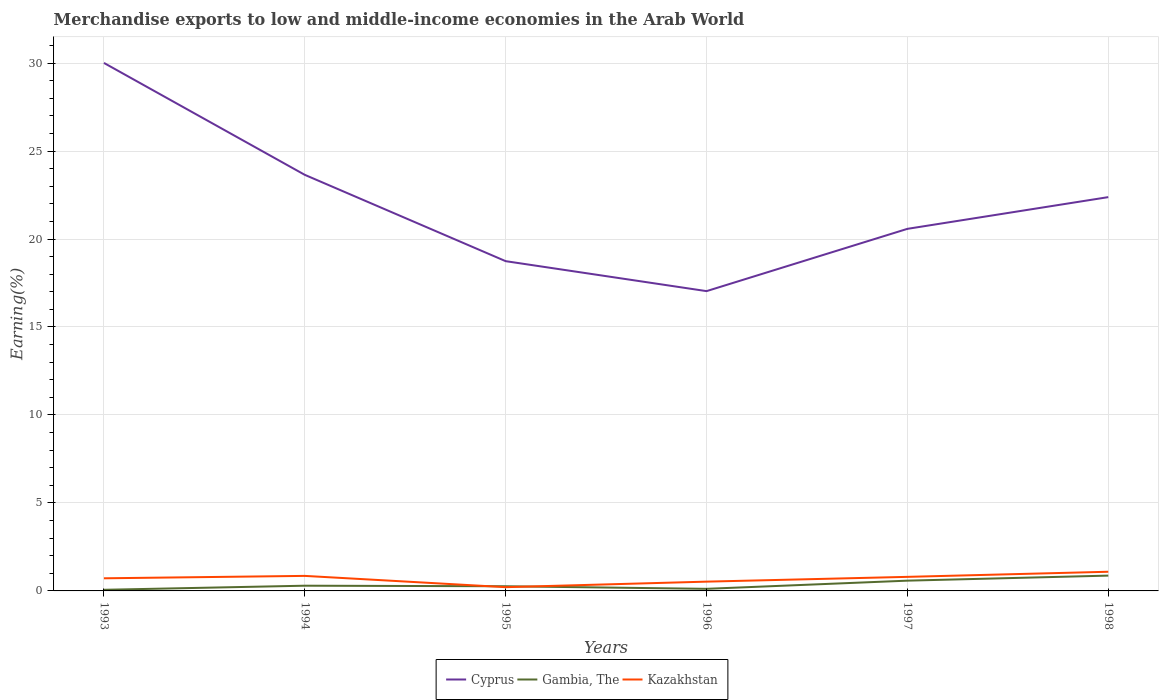How many different coloured lines are there?
Give a very brief answer. 3. Does the line corresponding to Kazakhstan intersect with the line corresponding to Cyprus?
Your response must be concise. No. Across all years, what is the maximum percentage of amount earned from merchandise exports in Cyprus?
Your answer should be very brief. 17.04. What is the total percentage of amount earned from merchandise exports in Cyprus in the graph?
Ensure brevity in your answer.  6.61. What is the difference between the highest and the second highest percentage of amount earned from merchandise exports in Kazakhstan?
Provide a short and direct response. 0.88. What is the difference between the highest and the lowest percentage of amount earned from merchandise exports in Cyprus?
Ensure brevity in your answer.  3. What is the difference between two consecutive major ticks on the Y-axis?
Ensure brevity in your answer.  5. Are the values on the major ticks of Y-axis written in scientific E-notation?
Your response must be concise. No. Does the graph contain grids?
Provide a succinct answer. Yes. Where does the legend appear in the graph?
Offer a very short reply. Bottom center. What is the title of the graph?
Ensure brevity in your answer.  Merchandise exports to low and middle-income economies in the Arab World. Does "Somalia" appear as one of the legend labels in the graph?
Offer a very short reply. No. What is the label or title of the X-axis?
Make the answer very short. Years. What is the label or title of the Y-axis?
Offer a very short reply. Earning(%). What is the Earning(%) of Cyprus in 1993?
Your response must be concise. 30.01. What is the Earning(%) of Gambia, The in 1993?
Provide a succinct answer. 0.06. What is the Earning(%) in Kazakhstan in 1993?
Your answer should be compact. 0.72. What is the Earning(%) of Cyprus in 1994?
Offer a terse response. 23.65. What is the Earning(%) of Gambia, The in 1994?
Give a very brief answer. 0.3. What is the Earning(%) of Kazakhstan in 1994?
Keep it short and to the point. 0.85. What is the Earning(%) of Cyprus in 1995?
Offer a very short reply. 18.74. What is the Earning(%) in Gambia, The in 1995?
Your answer should be very brief. 0.27. What is the Earning(%) of Kazakhstan in 1995?
Provide a succinct answer. 0.21. What is the Earning(%) in Cyprus in 1996?
Provide a succinct answer. 17.04. What is the Earning(%) of Gambia, The in 1996?
Offer a terse response. 0.12. What is the Earning(%) of Kazakhstan in 1996?
Make the answer very short. 0.53. What is the Earning(%) of Cyprus in 1997?
Keep it short and to the point. 20.58. What is the Earning(%) in Gambia, The in 1997?
Your answer should be compact. 0.58. What is the Earning(%) of Kazakhstan in 1997?
Provide a short and direct response. 0.8. What is the Earning(%) of Cyprus in 1998?
Offer a terse response. 22.38. What is the Earning(%) in Gambia, The in 1998?
Your answer should be very brief. 0.87. What is the Earning(%) of Kazakhstan in 1998?
Provide a succinct answer. 1.09. Across all years, what is the maximum Earning(%) of Cyprus?
Keep it short and to the point. 30.01. Across all years, what is the maximum Earning(%) in Gambia, The?
Provide a succinct answer. 0.87. Across all years, what is the maximum Earning(%) of Kazakhstan?
Give a very brief answer. 1.09. Across all years, what is the minimum Earning(%) in Cyprus?
Your response must be concise. 17.04. Across all years, what is the minimum Earning(%) in Gambia, The?
Ensure brevity in your answer.  0.06. Across all years, what is the minimum Earning(%) of Kazakhstan?
Offer a terse response. 0.21. What is the total Earning(%) in Cyprus in the graph?
Your answer should be compact. 132.39. What is the total Earning(%) of Gambia, The in the graph?
Your response must be concise. 2.2. What is the total Earning(%) in Kazakhstan in the graph?
Give a very brief answer. 4.2. What is the difference between the Earning(%) of Cyprus in 1993 and that in 1994?
Provide a short and direct response. 6.36. What is the difference between the Earning(%) of Gambia, The in 1993 and that in 1994?
Give a very brief answer. -0.23. What is the difference between the Earning(%) in Kazakhstan in 1993 and that in 1994?
Offer a very short reply. -0.14. What is the difference between the Earning(%) of Cyprus in 1993 and that in 1995?
Your answer should be compact. 11.27. What is the difference between the Earning(%) in Gambia, The in 1993 and that in 1995?
Keep it short and to the point. -0.2. What is the difference between the Earning(%) of Kazakhstan in 1993 and that in 1995?
Give a very brief answer. 0.5. What is the difference between the Earning(%) of Cyprus in 1993 and that in 1996?
Your response must be concise. 12.97. What is the difference between the Earning(%) of Gambia, The in 1993 and that in 1996?
Provide a succinct answer. -0.06. What is the difference between the Earning(%) in Kazakhstan in 1993 and that in 1996?
Keep it short and to the point. 0.19. What is the difference between the Earning(%) in Cyprus in 1993 and that in 1997?
Offer a terse response. 9.43. What is the difference between the Earning(%) of Gambia, The in 1993 and that in 1997?
Ensure brevity in your answer.  -0.52. What is the difference between the Earning(%) in Kazakhstan in 1993 and that in 1997?
Your answer should be very brief. -0.08. What is the difference between the Earning(%) in Cyprus in 1993 and that in 1998?
Offer a terse response. 7.63. What is the difference between the Earning(%) of Gambia, The in 1993 and that in 1998?
Your response must be concise. -0.81. What is the difference between the Earning(%) of Kazakhstan in 1993 and that in 1998?
Your answer should be very brief. -0.37. What is the difference between the Earning(%) of Cyprus in 1994 and that in 1995?
Provide a succinct answer. 4.91. What is the difference between the Earning(%) of Gambia, The in 1994 and that in 1995?
Your response must be concise. 0.03. What is the difference between the Earning(%) of Kazakhstan in 1994 and that in 1995?
Offer a very short reply. 0.64. What is the difference between the Earning(%) in Cyprus in 1994 and that in 1996?
Provide a short and direct response. 6.61. What is the difference between the Earning(%) in Gambia, The in 1994 and that in 1996?
Keep it short and to the point. 0.18. What is the difference between the Earning(%) in Kazakhstan in 1994 and that in 1996?
Your response must be concise. 0.33. What is the difference between the Earning(%) in Cyprus in 1994 and that in 1997?
Give a very brief answer. 3.07. What is the difference between the Earning(%) in Gambia, The in 1994 and that in 1997?
Ensure brevity in your answer.  -0.29. What is the difference between the Earning(%) of Kazakhstan in 1994 and that in 1997?
Offer a very short reply. 0.06. What is the difference between the Earning(%) of Cyprus in 1994 and that in 1998?
Ensure brevity in your answer.  1.27. What is the difference between the Earning(%) of Gambia, The in 1994 and that in 1998?
Offer a very short reply. -0.57. What is the difference between the Earning(%) of Kazakhstan in 1994 and that in 1998?
Provide a short and direct response. -0.24. What is the difference between the Earning(%) of Cyprus in 1995 and that in 1996?
Your response must be concise. 1.7. What is the difference between the Earning(%) of Gambia, The in 1995 and that in 1996?
Offer a very short reply. 0.15. What is the difference between the Earning(%) in Kazakhstan in 1995 and that in 1996?
Make the answer very short. -0.31. What is the difference between the Earning(%) of Cyprus in 1995 and that in 1997?
Provide a short and direct response. -1.84. What is the difference between the Earning(%) in Gambia, The in 1995 and that in 1997?
Offer a terse response. -0.32. What is the difference between the Earning(%) in Kazakhstan in 1995 and that in 1997?
Your response must be concise. -0.59. What is the difference between the Earning(%) of Cyprus in 1995 and that in 1998?
Ensure brevity in your answer.  -3.64. What is the difference between the Earning(%) of Gambia, The in 1995 and that in 1998?
Your response must be concise. -0.6. What is the difference between the Earning(%) in Kazakhstan in 1995 and that in 1998?
Provide a succinct answer. -0.88. What is the difference between the Earning(%) of Cyprus in 1996 and that in 1997?
Ensure brevity in your answer.  -3.54. What is the difference between the Earning(%) in Gambia, The in 1996 and that in 1997?
Keep it short and to the point. -0.46. What is the difference between the Earning(%) of Kazakhstan in 1996 and that in 1997?
Offer a very short reply. -0.27. What is the difference between the Earning(%) in Cyprus in 1996 and that in 1998?
Your answer should be very brief. -5.34. What is the difference between the Earning(%) of Gambia, The in 1996 and that in 1998?
Keep it short and to the point. -0.75. What is the difference between the Earning(%) in Kazakhstan in 1996 and that in 1998?
Give a very brief answer. -0.56. What is the difference between the Earning(%) of Cyprus in 1997 and that in 1998?
Provide a succinct answer. -1.8. What is the difference between the Earning(%) of Gambia, The in 1997 and that in 1998?
Provide a short and direct response. -0.29. What is the difference between the Earning(%) of Kazakhstan in 1997 and that in 1998?
Ensure brevity in your answer.  -0.29. What is the difference between the Earning(%) of Cyprus in 1993 and the Earning(%) of Gambia, The in 1994?
Give a very brief answer. 29.71. What is the difference between the Earning(%) of Cyprus in 1993 and the Earning(%) of Kazakhstan in 1994?
Your answer should be very brief. 29.15. What is the difference between the Earning(%) of Gambia, The in 1993 and the Earning(%) of Kazakhstan in 1994?
Your response must be concise. -0.79. What is the difference between the Earning(%) in Cyprus in 1993 and the Earning(%) in Gambia, The in 1995?
Make the answer very short. 29.74. What is the difference between the Earning(%) of Cyprus in 1993 and the Earning(%) of Kazakhstan in 1995?
Your answer should be very brief. 29.79. What is the difference between the Earning(%) of Gambia, The in 1993 and the Earning(%) of Kazakhstan in 1995?
Your answer should be compact. -0.15. What is the difference between the Earning(%) in Cyprus in 1993 and the Earning(%) in Gambia, The in 1996?
Your response must be concise. 29.89. What is the difference between the Earning(%) in Cyprus in 1993 and the Earning(%) in Kazakhstan in 1996?
Keep it short and to the point. 29.48. What is the difference between the Earning(%) of Gambia, The in 1993 and the Earning(%) of Kazakhstan in 1996?
Offer a very short reply. -0.46. What is the difference between the Earning(%) of Cyprus in 1993 and the Earning(%) of Gambia, The in 1997?
Your answer should be compact. 29.42. What is the difference between the Earning(%) in Cyprus in 1993 and the Earning(%) in Kazakhstan in 1997?
Your response must be concise. 29.21. What is the difference between the Earning(%) in Gambia, The in 1993 and the Earning(%) in Kazakhstan in 1997?
Give a very brief answer. -0.74. What is the difference between the Earning(%) of Cyprus in 1993 and the Earning(%) of Gambia, The in 1998?
Offer a very short reply. 29.14. What is the difference between the Earning(%) of Cyprus in 1993 and the Earning(%) of Kazakhstan in 1998?
Your answer should be very brief. 28.92. What is the difference between the Earning(%) of Gambia, The in 1993 and the Earning(%) of Kazakhstan in 1998?
Your response must be concise. -1.03. What is the difference between the Earning(%) of Cyprus in 1994 and the Earning(%) of Gambia, The in 1995?
Ensure brevity in your answer.  23.38. What is the difference between the Earning(%) of Cyprus in 1994 and the Earning(%) of Kazakhstan in 1995?
Provide a short and direct response. 23.43. What is the difference between the Earning(%) of Gambia, The in 1994 and the Earning(%) of Kazakhstan in 1995?
Provide a short and direct response. 0.08. What is the difference between the Earning(%) in Cyprus in 1994 and the Earning(%) in Gambia, The in 1996?
Give a very brief answer. 23.53. What is the difference between the Earning(%) in Cyprus in 1994 and the Earning(%) in Kazakhstan in 1996?
Offer a very short reply. 23.12. What is the difference between the Earning(%) in Gambia, The in 1994 and the Earning(%) in Kazakhstan in 1996?
Your response must be concise. -0.23. What is the difference between the Earning(%) in Cyprus in 1994 and the Earning(%) in Gambia, The in 1997?
Keep it short and to the point. 23.06. What is the difference between the Earning(%) in Cyprus in 1994 and the Earning(%) in Kazakhstan in 1997?
Provide a short and direct response. 22.85. What is the difference between the Earning(%) in Gambia, The in 1994 and the Earning(%) in Kazakhstan in 1997?
Your answer should be compact. -0.5. What is the difference between the Earning(%) of Cyprus in 1994 and the Earning(%) of Gambia, The in 1998?
Ensure brevity in your answer.  22.78. What is the difference between the Earning(%) in Cyprus in 1994 and the Earning(%) in Kazakhstan in 1998?
Make the answer very short. 22.56. What is the difference between the Earning(%) in Gambia, The in 1994 and the Earning(%) in Kazakhstan in 1998?
Provide a succinct answer. -0.79. What is the difference between the Earning(%) in Cyprus in 1995 and the Earning(%) in Gambia, The in 1996?
Provide a succinct answer. 18.62. What is the difference between the Earning(%) of Cyprus in 1995 and the Earning(%) of Kazakhstan in 1996?
Make the answer very short. 18.21. What is the difference between the Earning(%) of Gambia, The in 1995 and the Earning(%) of Kazakhstan in 1996?
Your answer should be very brief. -0.26. What is the difference between the Earning(%) of Cyprus in 1995 and the Earning(%) of Gambia, The in 1997?
Ensure brevity in your answer.  18.16. What is the difference between the Earning(%) of Cyprus in 1995 and the Earning(%) of Kazakhstan in 1997?
Your answer should be very brief. 17.94. What is the difference between the Earning(%) in Gambia, The in 1995 and the Earning(%) in Kazakhstan in 1997?
Ensure brevity in your answer.  -0.53. What is the difference between the Earning(%) in Cyprus in 1995 and the Earning(%) in Gambia, The in 1998?
Give a very brief answer. 17.87. What is the difference between the Earning(%) in Cyprus in 1995 and the Earning(%) in Kazakhstan in 1998?
Your response must be concise. 17.65. What is the difference between the Earning(%) in Gambia, The in 1995 and the Earning(%) in Kazakhstan in 1998?
Ensure brevity in your answer.  -0.82. What is the difference between the Earning(%) in Cyprus in 1996 and the Earning(%) in Gambia, The in 1997?
Your response must be concise. 16.45. What is the difference between the Earning(%) of Cyprus in 1996 and the Earning(%) of Kazakhstan in 1997?
Ensure brevity in your answer.  16.24. What is the difference between the Earning(%) in Gambia, The in 1996 and the Earning(%) in Kazakhstan in 1997?
Your answer should be compact. -0.68. What is the difference between the Earning(%) in Cyprus in 1996 and the Earning(%) in Gambia, The in 1998?
Your answer should be very brief. 16.17. What is the difference between the Earning(%) in Cyprus in 1996 and the Earning(%) in Kazakhstan in 1998?
Give a very brief answer. 15.95. What is the difference between the Earning(%) in Gambia, The in 1996 and the Earning(%) in Kazakhstan in 1998?
Make the answer very short. -0.97. What is the difference between the Earning(%) of Cyprus in 1997 and the Earning(%) of Gambia, The in 1998?
Your answer should be compact. 19.71. What is the difference between the Earning(%) in Cyprus in 1997 and the Earning(%) in Kazakhstan in 1998?
Give a very brief answer. 19.49. What is the difference between the Earning(%) in Gambia, The in 1997 and the Earning(%) in Kazakhstan in 1998?
Ensure brevity in your answer.  -0.51. What is the average Earning(%) in Cyprus per year?
Give a very brief answer. 22.06. What is the average Earning(%) in Gambia, The per year?
Provide a succinct answer. 0.37. What is the average Earning(%) of Kazakhstan per year?
Give a very brief answer. 0.7. In the year 1993, what is the difference between the Earning(%) in Cyprus and Earning(%) in Gambia, The?
Provide a succinct answer. 29.94. In the year 1993, what is the difference between the Earning(%) in Cyprus and Earning(%) in Kazakhstan?
Your answer should be very brief. 29.29. In the year 1993, what is the difference between the Earning(%) in Gambia, The and Earning(%) in Kazakhstan?
Your answer should be very brief. -0.65. In the year 1994, what is the difference between the Earning(%) of Cyprus and Earning(%) of Gambia, The?
Make the answer very short. 23.35. In the year 1994, what is the difference between the Earning(%) in Cyprus and Earning(%) in Kazakhstan?
Provide a succinct answer. 22.79. In the year 1994, what is the difference between the Earning(%) in Gambia, The and Earning(%) in Kazakhstan?
Offer a terse response. -0.56. In the year 1995, what is the difference between the Earning(%) of Cyprus and Earning(%) of Gambia, The?
Provide a succinct answer. 18.47. In the year 1995, what is the difference between the Earning(%) of Cyprus and Earning(%) of Kazakhstan?
Your answer should be very brief. 18.53. In the year 1995, what is the difference between the Earning(%) in Gambia, The and Earning(%) in Kazakhstan?
Give a very brief answer. 0.05. In the year 1996, what is the difference between the Earning(%) in Cyprus and Earning(%) in Gambia, The?
Give a very brief answer. 16.92. In the year 1996, what is the difference between the Earning(%) in Cyprus and Earning(%) in Kazakhstan?
Make the answer very short. 16.51. In the year 1996, what is the difference between the Earning(%) in Gambia, The and Earning(%) in Kazakhstan?
Provide a short and direct response. -0.41. In the year 1997, what is the difference between the Earning(%) in Cyprus and Earning(%) in Gambia, The?
Keep it short and to the point. 19.99. In the year 1997, what is the difference between the Earning(%) in Cyprus and Earning(%) in Kazakhstan?
Offer a very short reply. 19.78. In the year 1997, what is the difference between the Earning(%) of Gambia, The and Earning(%) of Kazakhstan?
Keep it short and to the point. -0.22. In the year 1998, what is the difference between the Earning(%) in Cyprus and Earning(%) in Gambia, The?
Keep it short and to the point. 21.51. In the year 1998, what is the difference between the Earning(%) of Cyprus and Earning(%) of Kazakhstan?
Your response must be concise. 21.29. In the year 1998, what is the difference between the Earning(%) of Gambia, The and Earning(%) of Kazakhstan?
Provide a succinct answer. -0.22. What is the ratio of the Earning(%) of Cyprus in 1993 to that in 1994?
Your response must be concise. 1.27. What is the ratio of the Earning(%) of Gambia, The in 1993 to that in 1994?
Make the answer very short. 0.21. What is the ratio of the Earning(%) in Kazakhstan in 1993 to that in 1994?
Offer a terse response. 0.84. What is the ratio of the Earning(%) of Cyprus in 1993 to that in 1995?
Your response must be concise. 1.6. What is the ratio of the Earning(%) in Gambia, The in 1993 to that in 1995?
Provide a short and direct response. 0.24. What is the ratio of the Earning(%) in Kazakhstan in 1993 to that in 1995?
Your response must be concise. 3.37. What is the ratio of the Earning(%) of Cyprus in 1993 to that in 1996?
Your response must be concise. 1.76. What is the ratio of the Earning(%) in Gambia, The in 1993 to that in 1996?
Give a very brief answer. 0.54. What is the ratio of the Earning(%) in Kazakhstan in 1993 to that in 1996?
Your answer should be very brief. 1.36. What is the ratio of the Earning(%) of Cyprus in 1993 to that in 1997?
Your answer should be very brief. 1.46. What is the ratio of the Earning(%) of Gambia, The in 1993 to that in 1997?
Your answer should be compact. 0.11. What is the ratio of the Earning(%) of Kazakhstan in 1993 to that in 1997?
Keep it short and to the point. 0.9. What is the ratio of the Earning(%) in Cyprus in 1993 to that in 1998?
Offer a terse response. 1.34. What is the ratio of the Earning(%) of Gambia, The in 1993 to that in 1998?
Ensure brevity in your answer.  0.07. What is the ratio of the Earning(%) in Kazakhstan in 1993 to that in 1998?
Your answer should be compact. 0.66. What is the ratio of the Earning(%) in Cyprus in 1994 to that in 1995?
Provide a succinct answer. 1.26. What is the ratio of the Earning(%) of Gambia, The in 1994 to that in 1995?
Ensure brevity in your answer.  1.12. What is the ratio of the Earning(%) in Kazakhstan in 1994 to that in 1995?
Offer a terse response. 4.01. What is the ratio of the Earning(%) in Cyprus in 1994 to that in 1996?
Your answer should be compact. 1.39. What is the ratio of the Earning(%) of Gambia, The in 1994 to that in 1996?
Your answer should be compact. 2.5. What is the ratio of the Earning(%) of Kazakhstan in 1994 to that in 1996?
Provide a succinct answer. 1.62. What is the ratio of the Earning(%) in Cyprus in 1994 to that in 1997?
Your answer should be compact. 1.15. What is the ratio of the Earning(%) in Gambia, The in 1994 to that in 1997?
Make the answer very short. 0.51. What is the ratio of the Earning(%) of Kazakhstan in 1994 to that in 1997?
Your answer should be compact. 1.07. What is the ratio of the Earning(%) in Cyprus in 1994 to that in 1998?
Keep it short and to the point. 1.06. What is the ratio of the Earning(%) of Gambia, The in 1994 to that in 1998?
Your response must be concise. 0.34. What is the ratio of the Earning(%) in Kazakhstan in 1994 to that in 1998?
Offer a terse response. 0.78. What is the ratio of the Earning(%) of Cyprus in 1995 to that in 1996?
Your answer should be compact. 1.1. What is the ratio of the Earning(%) in Gambia, The in 1995 to that in 1996?
Your answer should be very brief. 2.23. What is the ratio of the Earning(%) of Kazakhstan in 1995 to that in 1996?
Give a very brief answer. 0.4. What is the ratio of the Earning(%) in Cyprus in 1995 to that in 1997?
Offer a very short reply. 0.91. What is the ratio of the Earning(%) in Gambia, The in 1995 to that in 1997?
Ensure brevity in your answer.  0.46. What is the ratio of the Earning(%) in Kazakhstan in 1995 to that in 1997?
Your answer should be compact. 0.27. What is the ratio of the Earning(%) of Cyprus in 1995 to that in 1998?
Your answer should be very brief. 0.84. What is the ratio of the Earning(%) in Gambia, The in 1995 to that in 1998?
Provide a succinct answer. 0.31. What is the ratio of the Earning(%) of Kazakhstan in 1995 to that in 1998?
Your answer should be compact. 0.2. What is the ratio of the Earning(%) of Cyprus in 1996 to that in 1997?
Your response must be concise. 0.83. What is the ratio of the Earning(%) in Gambia, The in 1996 to that in 1997?
Keep it short and to the point. 0.2. What is the ratio of the Earning(%) of Kazakhstan in 1996 to that in 1997?
Offer a terse response. 0.66. What is the ratio of the Earning(%) in Cyprus in 1996 to that in 1998?
Make the answer very short. 0.76. What is the ratio of the Earning(%) of Gambia, The in 1996 to that in 1998?
Offer a very short reply. 0.14. What is the ratio of the Earning(%) in Kazakhstan in 1996 to that in 1998?
Offer a terse response. 0.48. What is the ratio of the Earning(%) of Cyprus in 1997 to that in 1998?
Provide a short and direct response. 0.92. What is the ratio of the Earning(%) of Gambia, The in 1997 to that in 1998?
Keep it short and to the point. 0.67. What is the ratio of the Earning(%) of Kazakhstan in 1997 to that in 1998?
Your response must be concise. 0.73. What is the difference between the highest and the second highest Earning(%) in Cyprus?
Keep it short and to the point. 6.36. What is the difference between the highest and the second highest Earning(%) of Gambia, The?
Your response must be concise. 0.29. What is the difference between the highest and the second highest Earning(%) of Kazakhstan?
Offer a very short reply. 0.24. What is the difference between the highest and the lowest Earning(%) of Cyprus?
Provide a short and direct response. 12.97. What is the difference between the highest and the lowest Earning(%) in Gambia, The?
Offer a terse response. 0.81. What is the difference between the highest and the lowest Earning(%) in Kazakhstan?
Offer a terse response. 0.88. 